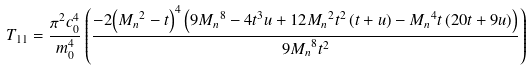Convert formula to latex. <formula><loc_0><loc_0><loc_500><loc_500>T _ { 1 1 } = \frac { \pi ^ { 2 } c _ { 0 } ^ { 4 } } { m _ { 0 } ^ { 4 } } \left ( \frac { - 2 { \left ( { M _ { n } } ^ { 2 } - t \right ) } ^ { 4 } \left ( 9 { M _ { n } } ^ { 8 } - 4 t ^ { 3 } u + 1 2 { M _ { n } } ^ { 2 } t ^ { 2 } \left ( t + u \right ) - { M _ { n } } ^ { 4 } t \left ( 2 0 t + 9 u \right ) \right ) } { 9 { M _ { n } } ^ { 8 } t ^ { 2 } } \right )</formula> 